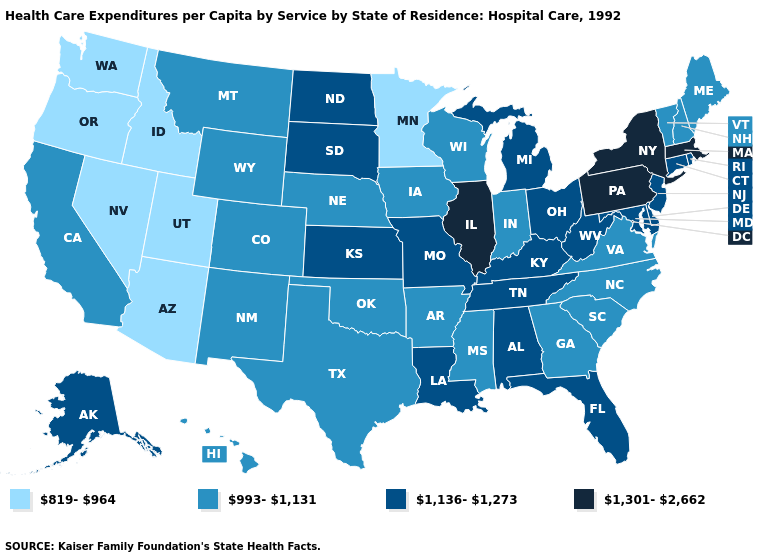Among the states that border Florida , which have the lowest value?
Answer briefly. Georgia. Among the states that border Ohio , which have the highest value?
Concise answer only. Pennsylvania. Name the states that have a value in the range 993-1,131?
Be succinct. Arkansas, California, Colorado, Georgia, Hawaii, Indiana, Iowa, Maine, Mississippi, Montana, Nebraska, New Hampshire, New Mexico, North Carolina, Oklahoma, South Carolina, Texas, Vermont, Virginia, Wisconsin, Wyoming. Does the map have missing data?
Write a very short answer. No. Does Massachusetts have the same value as South Carolina?
Quick response, please. No. What is the value of Connecticut?
Keep it brief. 1,136-1,273. What is the value of Louisiana?
Quick response, please. 1,136-1,273. Name the states that have a value in the range 993-1,131?
Concise answer only. Arkansas, California, Colorado, Georgia, Hawaii, Indiana, Iowa, Maine, Mississippi, Montana, Nebraska, New Hampshire, New Mexico, North Carolina, Oklahoma, South Carolina, Texas, Vermont, Virginia, Wisconsin, Wyoming. What is the value of South Dakota?
Give a very brief answer. 1,136-1,273. What is the highest value in the USA?
Short answer required. 1,301-2,662. Does New Jersey have the highest value in the USA?
Short answer required. No. What is the lowest value in the USA?
Give a very brief answer. 819-964. Does the map have missing data?
Write a very short answer. No. What is the lowest value in the South?
Short answer required. 993-1,131. What is the value of Florida?
Be succinct. 1,136-1,273. 